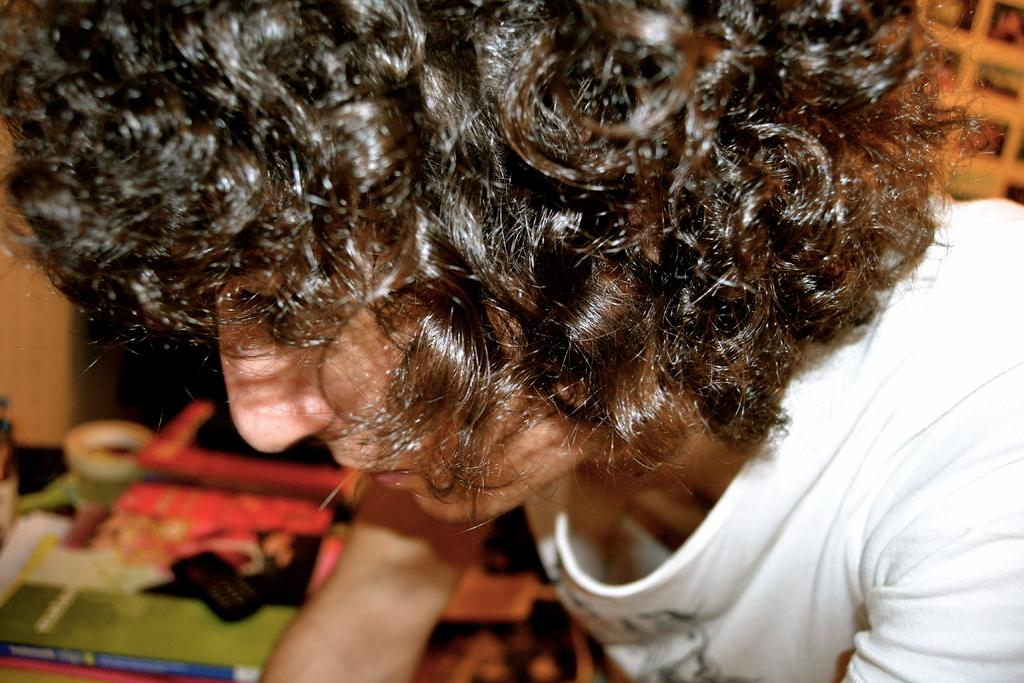What can be seen in the image? There is a person in the image. What can be found at the bottom of the image? There are objects at the bottom of the image. What type of argument is the monkey having with the person in the image? There is no monkey present in the image, so it is not possible to determine if there is an argument or any interaction between a monkey and the person. 